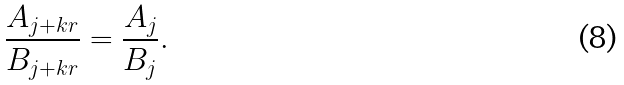Convert formula to latex. <formula><loc_0><loc_0><loc_500><loc_500>\frac { A _ { j + k r } } { B _ { j + k r } } = \frac { A _ { j } } { B _ { j } } .</formula> 